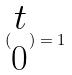<formula> <loc_0><loc_0><loc_500><loc_500>( \begin{matrix} t \\ 0 \end{matrix} ) = 1</formula> 